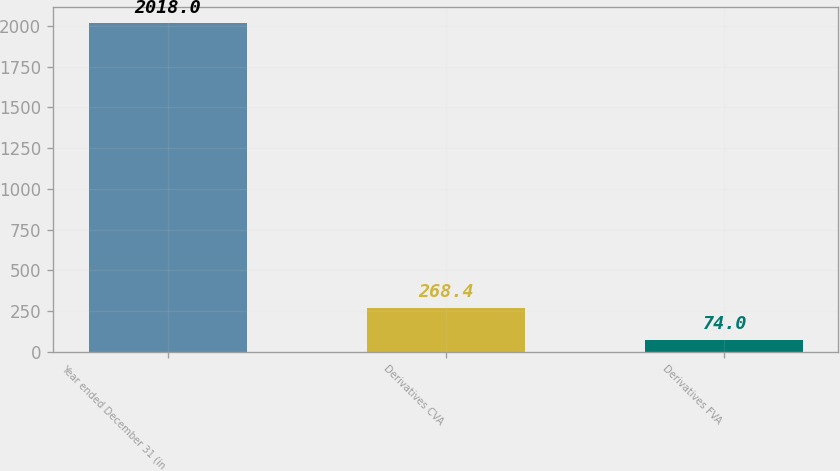Convert chart to OTSL. <chart><loc_0><loc_0><loc_500><loc_500><bar_chart><fcel>Year ended December 31 (in<fcel>Derivatives CVA<fcel>Derivatives FVA<nl><fcel>2018<fcel>268.4<fcel>74<nl></chart> 